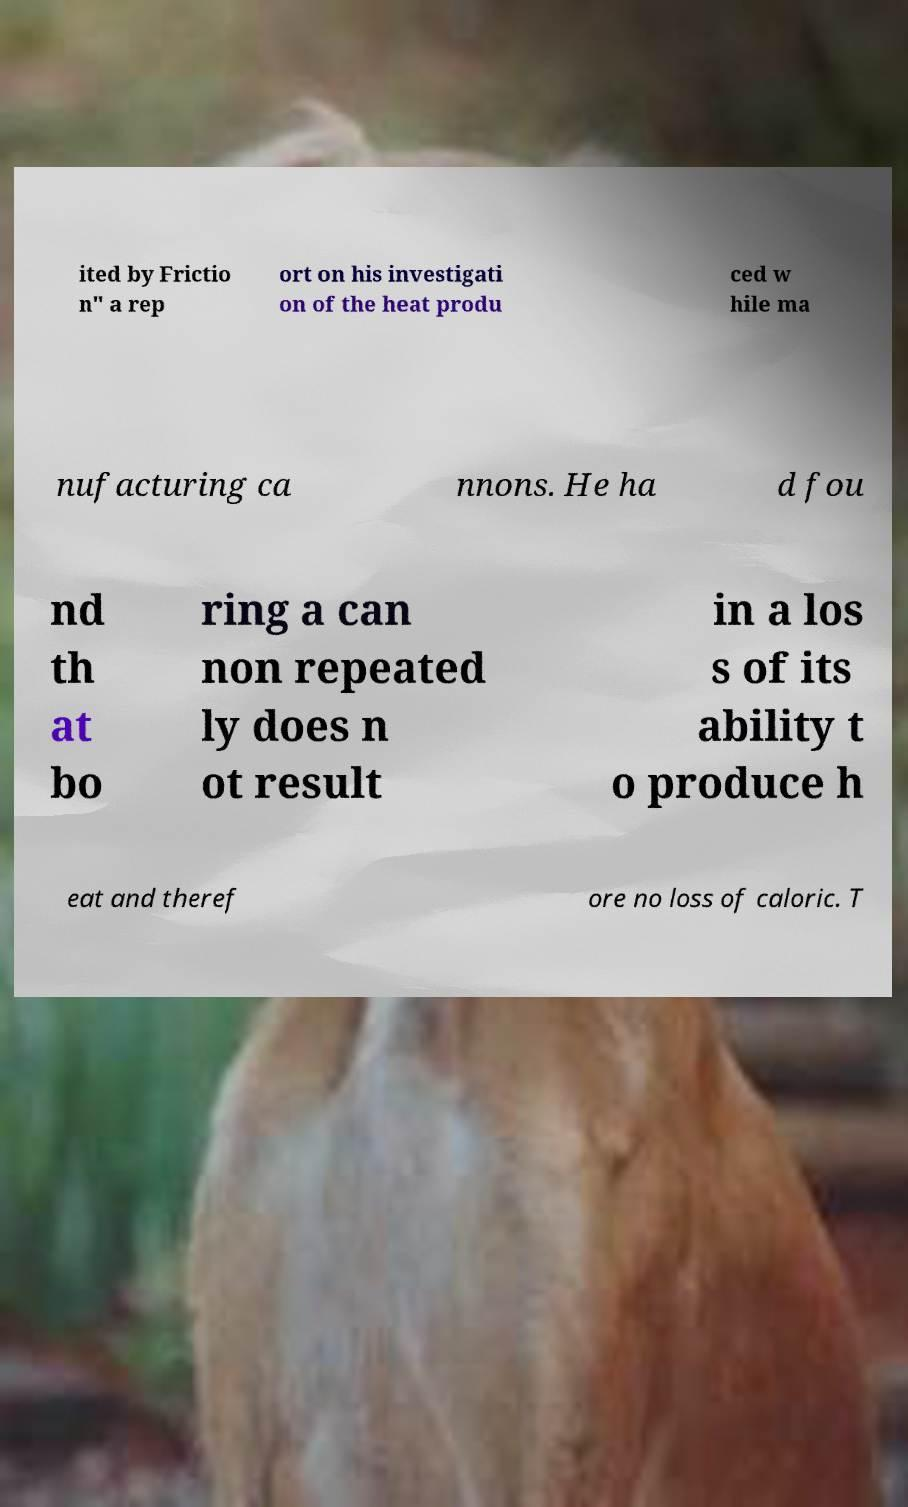Please identify and transcribe the text found in this image. ited by Frictio n" a rep ort on his investigati on of the heat produ ced w hile ma nufacturing ca nnons. He ha d fou nd th at bo ring a can non repeated ly does n ot result in a los s of its ability t o produce h eat and theref ore no loss of caloric. T 